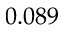<formula> <loc_0><loc_0><loc_500><loc_500>0 . 0 8 9</formula> 